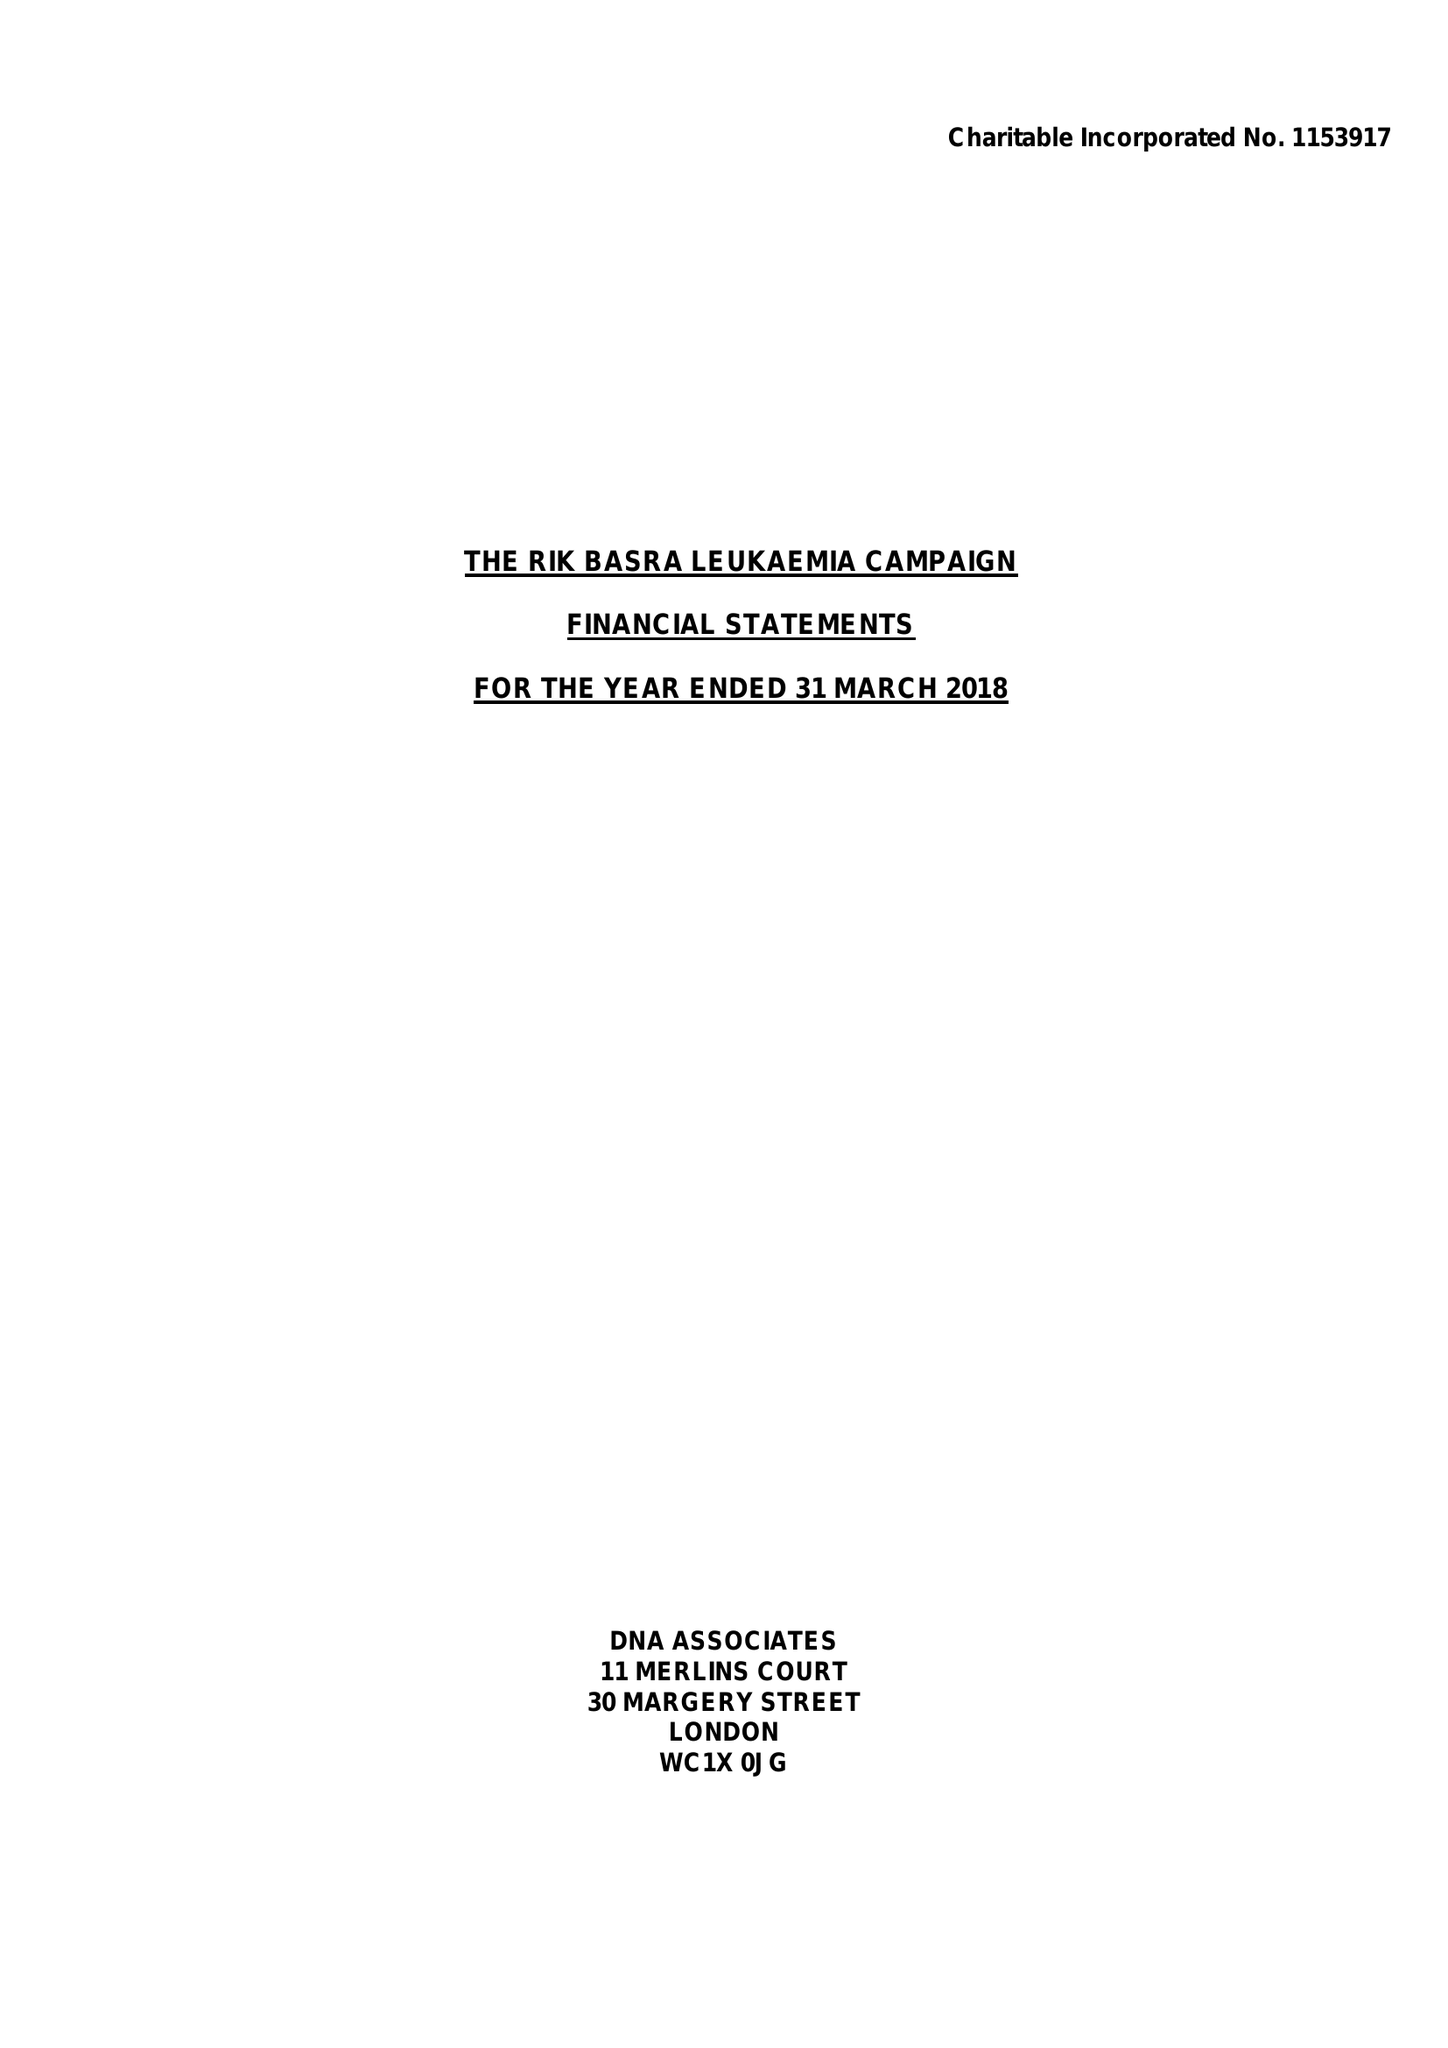What is the value for the charity_name?
Answer the question using a single word or phrase. The Rik Basra Leukaemia Campaign 